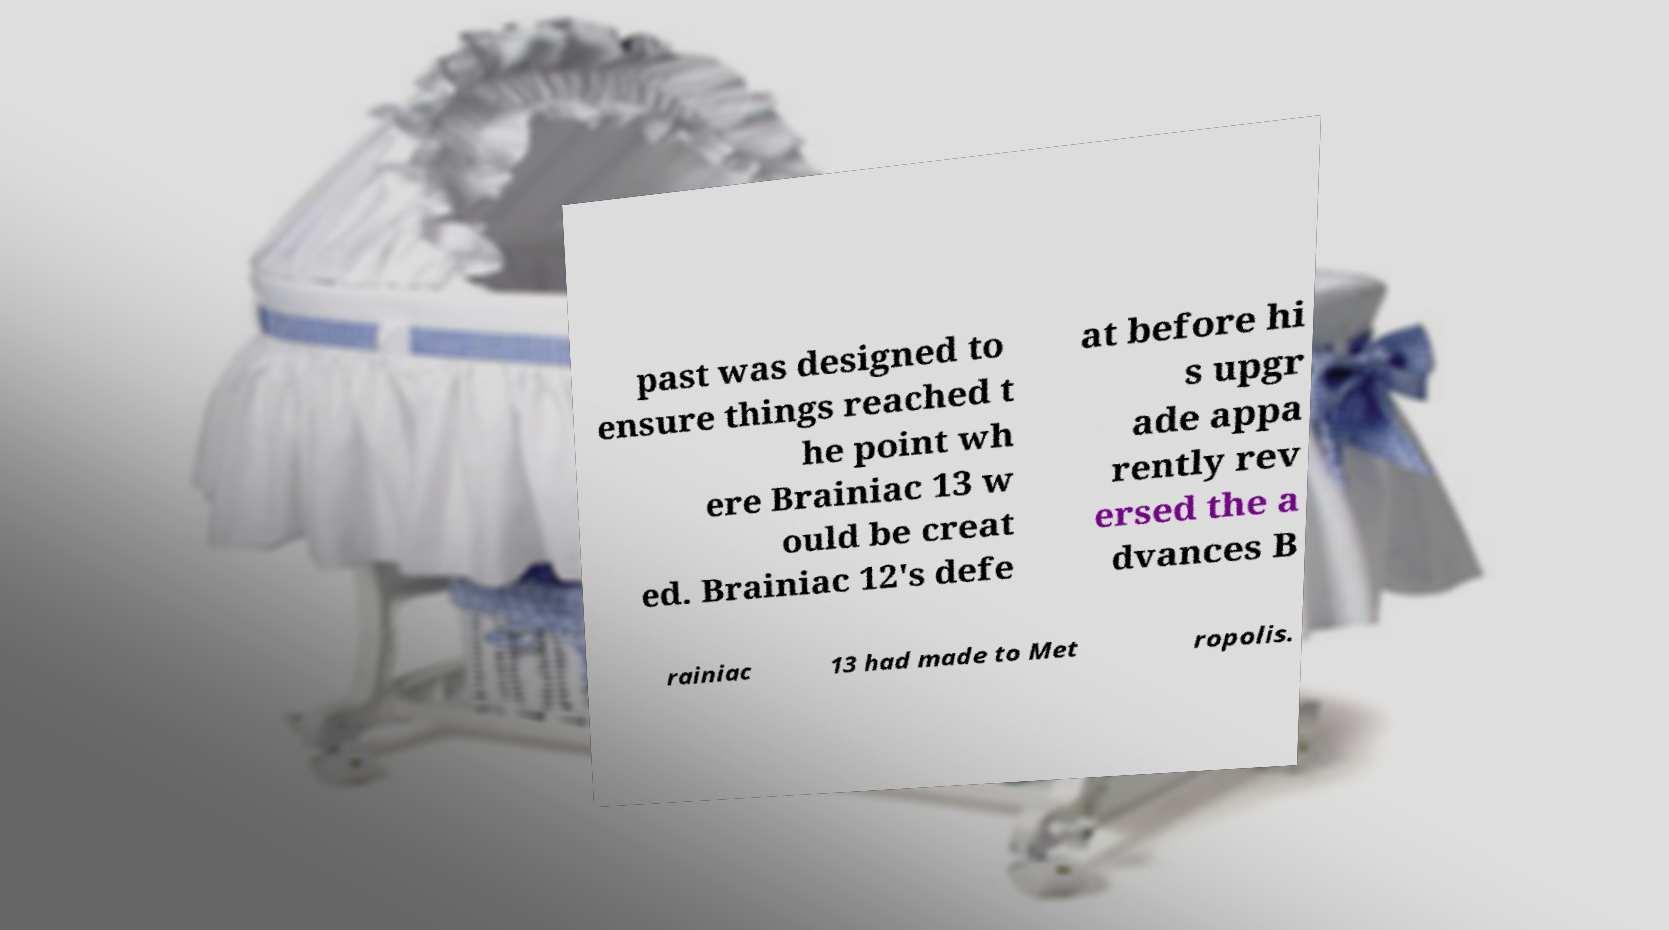Can you read and provide the text displayed in the image?This photo seems to have some interesting text. Can you extract and type it out for me? past was designed to ensure things reached t he point wh ere Brainiac 13 w ould be creat ed. Brainiac 12's defe at before hi s upgr ade appa rently rev ersed the a dvances B rainiac 13 had made to Met ropolis. 